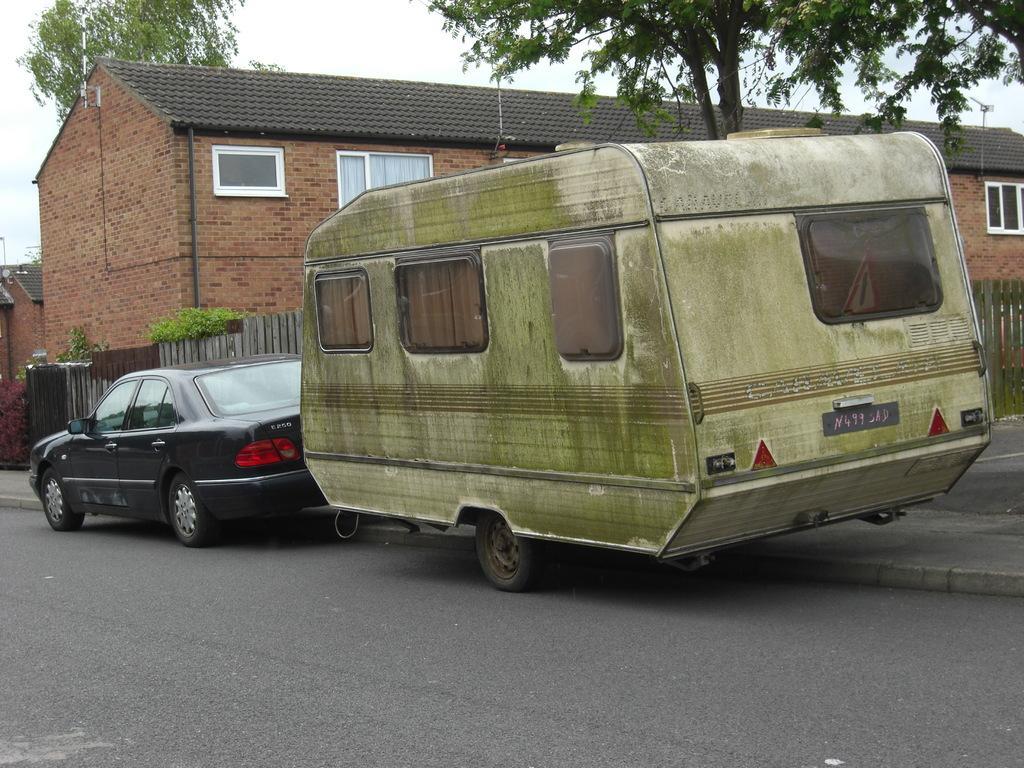Could you give a brief overview of what you see in this image? In this image we can see some vehicles on the road. On the backside we can see a house with windows, a fence, plants, trees and the sky. 